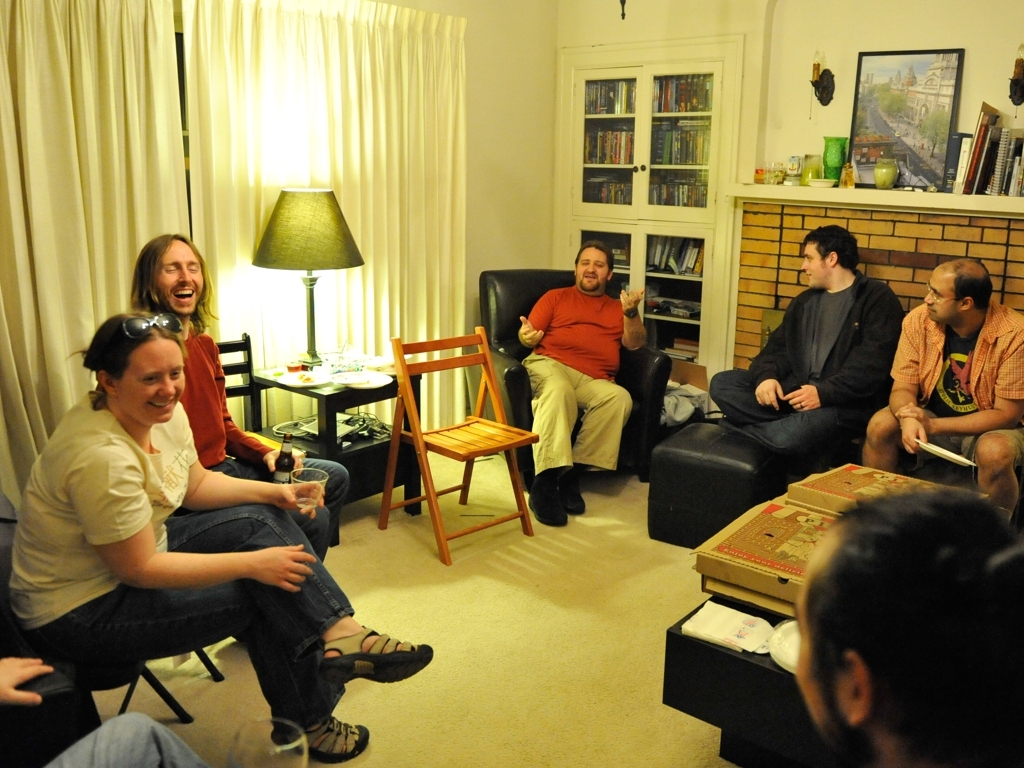Can the main subjects be identified clearly? Indeed, the main subjects in the image — a group of people gathered in a living space, engaged in a social event — are identifiable with great clarity. The lighting is soft but ample, and each person is visible with distinctive features and expressions, contributing to the warm, convivial atmosphere of the scene. 